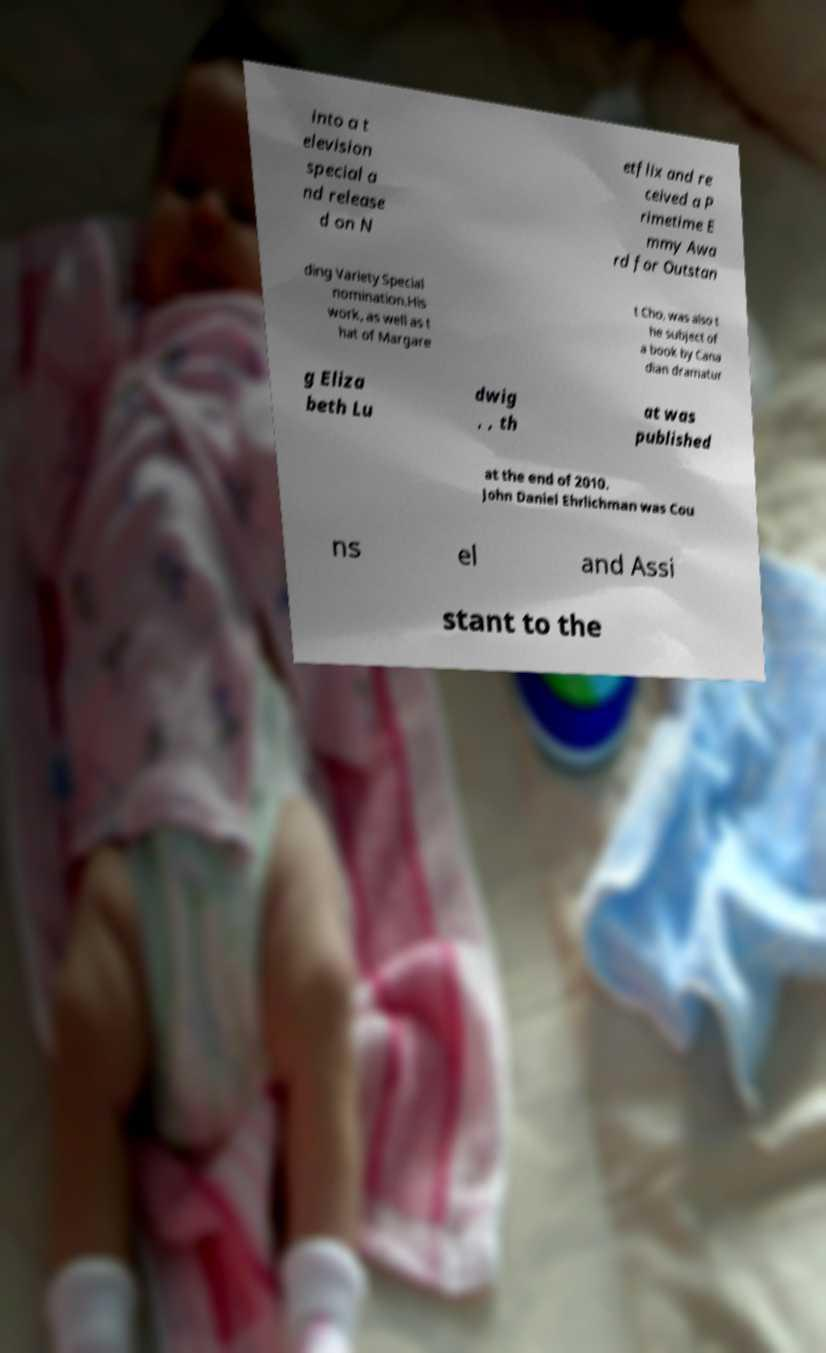Can you accurately transcribe the text from the provided image for me? into a t elevision special a nd release d on N etflix and re ceived a P rimetime E mmy Awa rd for Outstan ding Variety Special nomination.His work, as well as t hat of Margare t Cho, was also t he subject of a book by Cana dian dramatur g Eliza beth Lu dwig , , th at was published at the end of 2010. John Daniel Ehrlichman was Cou ns el and Assi stant to the 